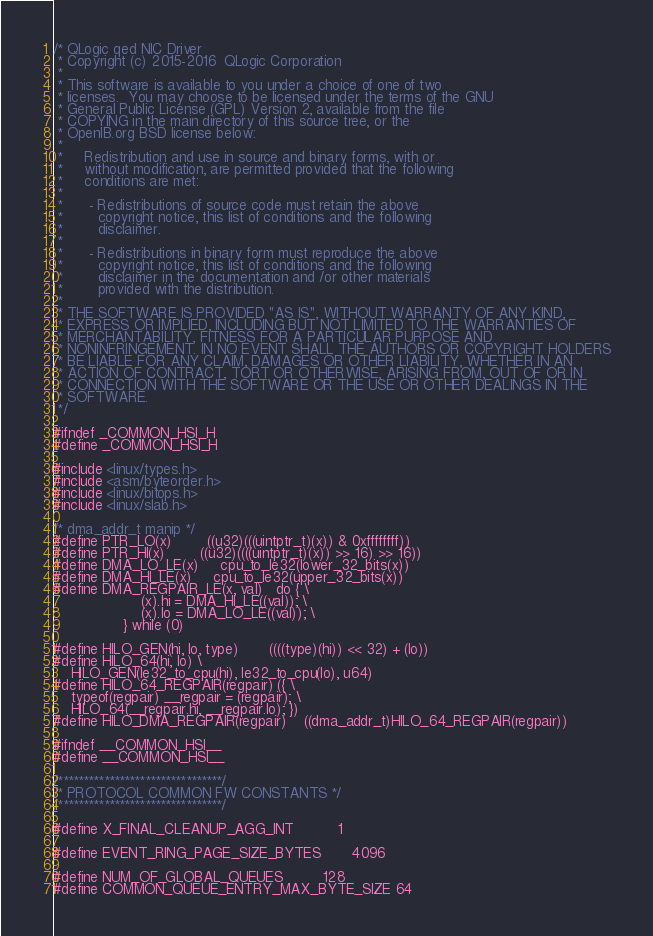<code> <loc_0><loc_0><loc_500><loc_500><_C_>/* QLogic qed NIC Driver
 * Copyright (c) 2015-2016  QLogic Corporation
 *
 * This software is available to you under a choice of one of two
 * licenses.  You may choose to be licensed under the terms of the GNU
 * General Public License (GPL) Version 2, available from the file
 * COPYING in the main directory of this source tree, or the
 * OpenIB.org BSD license below:
 *
 *     Redistribution and use in source and binary forms, with or
 *     without modification, are permitted provided that the following
 *     conditions are met:
 *
 *      - Redistributions of source code must retain the above
 *        copyright notice, this list of conditions and the following
 *        disclaimer.
 *
 *      - Redistributions in binary form must reproduce the above
 *        copyright notice, this list of conditions and the following
 *        disclaimer in the documentation and /or other materials
 *        provided with the distribution.
 *
 * THE SOFTWARE IS PROVIDED "AS IS", WITHOUT WARRANTY OF ANY KIND,
 * EXPRESS OR IMPLIED, INCLUDING BUT NOT LIMITED TO THE WARRANTIES OF
 * MERCHANTABILITY, FITNESS FOR A PARTICULAR PURPOSE AND
 * NONINFRINGEMENT. IN NO EVENT SHALL THE AUTHORS OR COPYRIGHT HOLDERS
 * BE LIABLE FOR ANY CLAIM, DAMAGES OR OTHER LIABILITY, WHETHER IN AN
 * ACTION OF CONTRACT, TORT OR OTHERWISE, ARISING FROM, OUT OF OR IN
 * CONNECTION WITH THE SOFTWARE OR THE USE OR OTHER DEALINGS IN THE
 * SOFTWARE.
 */

#ifndef _COMMON_HSI_H
#define _COMMON_HSI_H

#include <linux/types.h>
#include <asm/byteorder.h>
#include <linux/bitops.h>
#include <linux/slab.h>

/* dma_addr_t manip */
#define PTR_LO(x)		((u32)(((uintptr_t)(x)) & 0xffffffff))
#define PTR_HI(x)		((u32)((((uintptr_t)(x)) >> 16) >> 16))
#define DMA_LO_LE(x)		cpu_to_le32(lower_32_bits(x))
#define DMA_HI_LE(x)		cpu_to_le32(upper_32_bits(x))
#define DMA_REGPAIR_LE(x, val)	do { \
					(x).hi = DMA_HI_LE((val)); \
					(x).lo = DMA_LO_LE((val)); \
				} while (0)

#define HILO_GEN(hi, lo, type)		((((type)(hi)) << 32) + (lo))
#define HILO_64(hi, lo) \
	HILO_GEN(le32_to_cpu(hi), le32_to_cpu(lo), u64)
#define HILO_64_REGPAIR(regpair) ({ \
	typeof(regpair) __regpair = (regpair); \
	HILO_64(__regpair.hi, __regpair.lo); })
#define HILO_DMA_REGPAIR(regpair)	((dma_addr_t)HILO_64_REGPAIR(regpair))

#ifndef __COMMON_HSI__
#define __COMMON_HSI__

/********************************/
/* PROTOCOL COMMON FW CONSTANTS */
/********************************/

#define X_FINAL_CLEANUP_AGG_INT			1

#define EVENT_RING_PAGE_SIZE_BYTES		4096

#define NUM_OF_GLOBAL_QUEUES			128
#define COMMON_QUEUE_ENTRY_MAX_BYTE_SIZE	64
</code> 